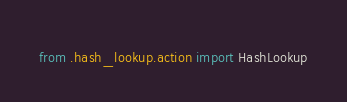Convert code to text. <code><loc_0><loc_0><loc_500><loc_500><_Python_>from .hash_lookup.action import HashLookup
</code> 